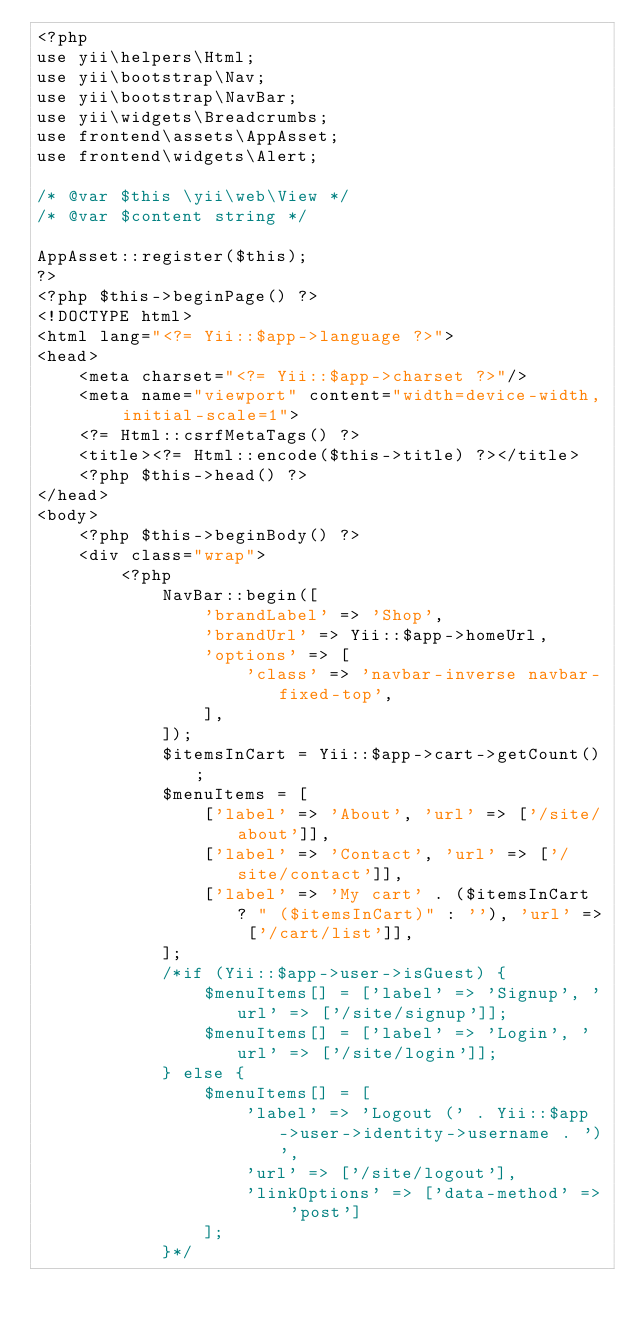Convert code to text. <code><loc_0><loc_0><loc_500><loc_500><_PHP_><?php
use yii\helpers\Html;
use yii\bootstrap\Nav;
use yii\bootstrap\NavBar;
use yii\widgets\Breadcrumbs;
use frontend\assets\AppAsset;
use frontend\widgets\Alert;

/* @var $this \yii\web\View */
/* @var $content string */

AppAsset::register($this);
?>
<?php $this->beginPage() ?>
<!DOCTYPE html>
<html lang="<?= Yii::$app->language ?>">
<head>
    <meta charset="<?= Yii::$app->charset ?>"/>
    <meta name="viewport" content="width=device-width, initial-scale=1">
    <?= Html::csrfMetaTags() ?>
    <title><?= Html::encode($this->title) ?></title>
    <?php $this->head() ?>
</head>
<body>
    <?php $this->beginBody() ?>
    <div class="wrap">
        <?php
            NavBar::begin([
                'brandLabel' => 'Shop',
                'brandUrl' => Yii::$app->homeUrl,
                'options' => [
                    'class' => 'navbar-inverse navbar-fixed-top',
                ],
            ]);
            $itemsInCart = Yii::$app->cart->getCount();
            $menuItems = [
                ['label' => 'About', 'url' => ['/site/about']],
                ['label' => 'Contact', 'url' => ['/site/contact']],
                ['label' => 'My cart' . ($itemsInCart ? " ($itemsInCart)" : ''), 'url' => ['/cart/list']],
            ];
            /*if (Yii::$app->user->isGuest) {
                $menuItems[] = ['label' => 'Signup', 'url' => ['/site/signup']];
                $menuItems[] = ['label' => 'Login', 'url' => ['/site/login']];
            } else {
                $menuItems[] = [
                    'label' => 'Logout (' . Yii::$app->user->identity->username . ')',
                    'url' => ['/site/logout'],
                    'linkOptions' => ['data-method' => 'post']
                ];
            }*/</code> 